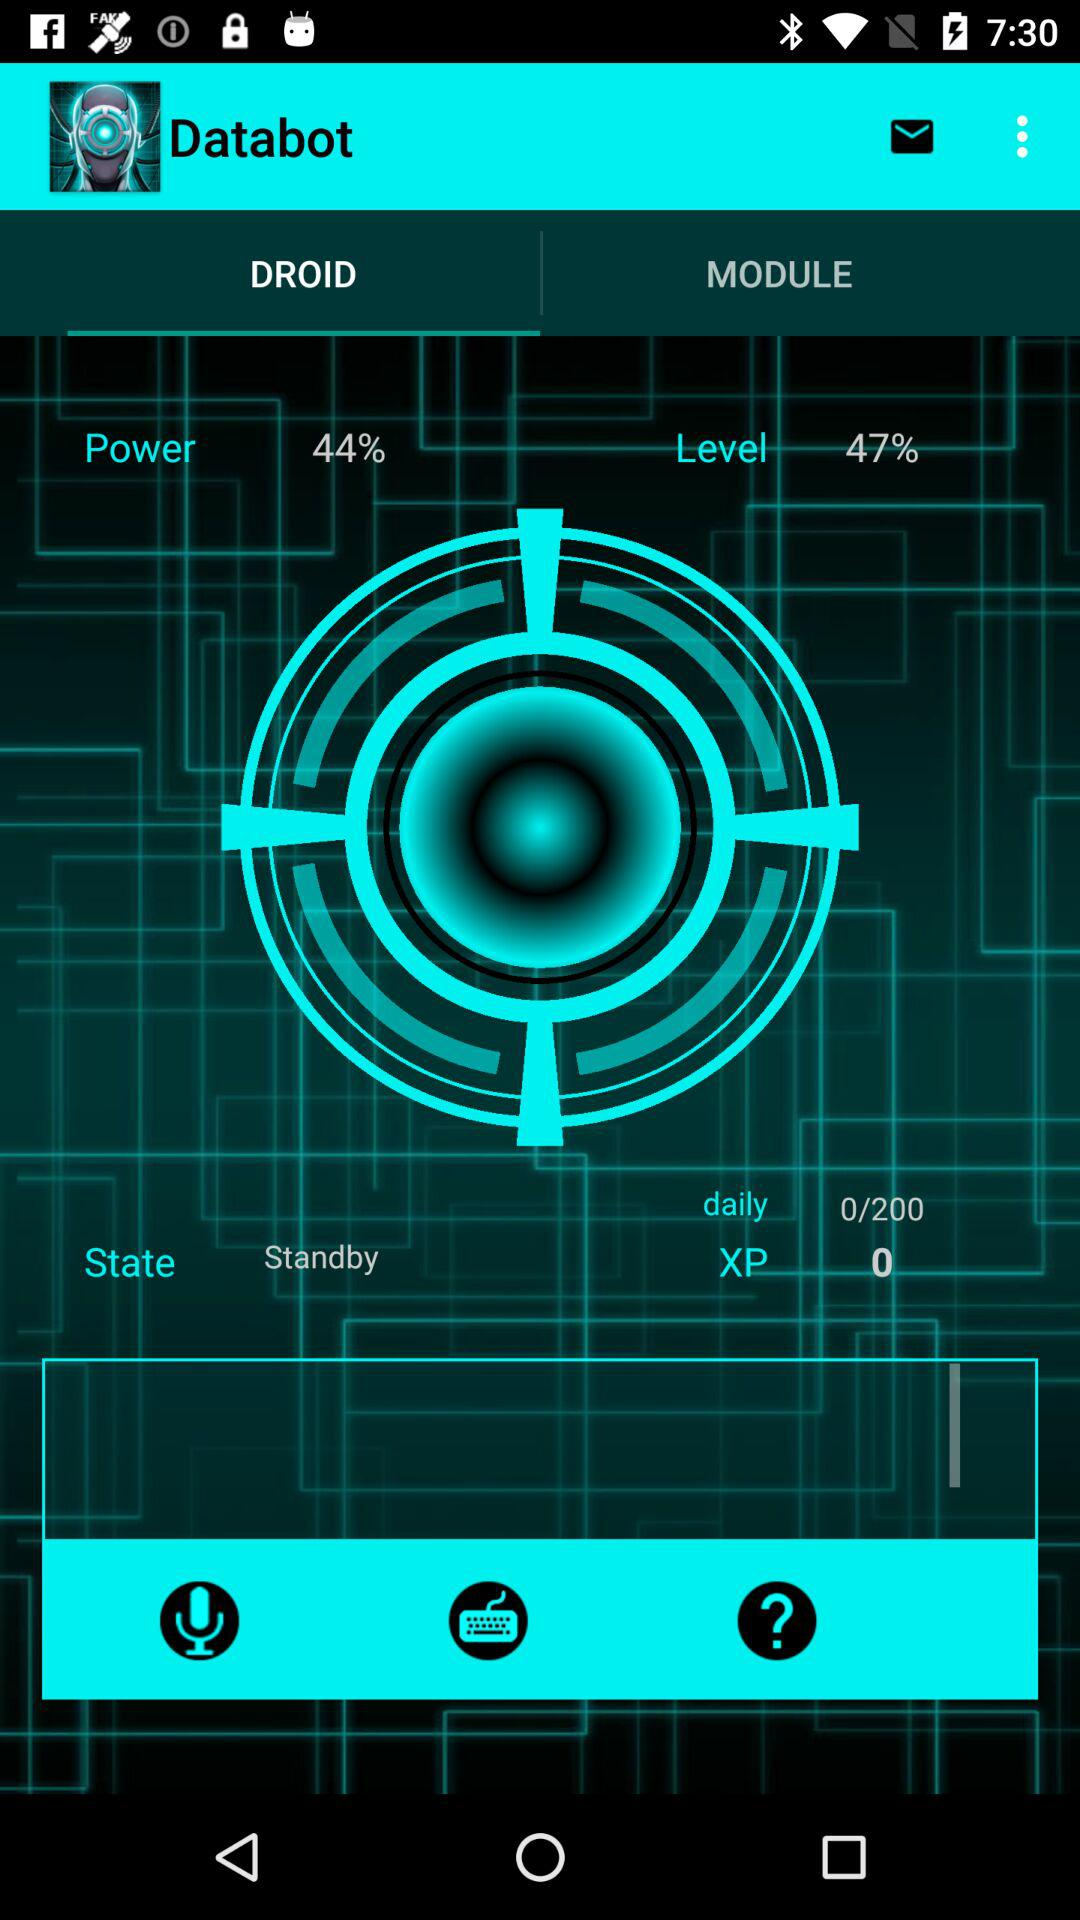What is the percentage of power? the percentage of power is 44. 